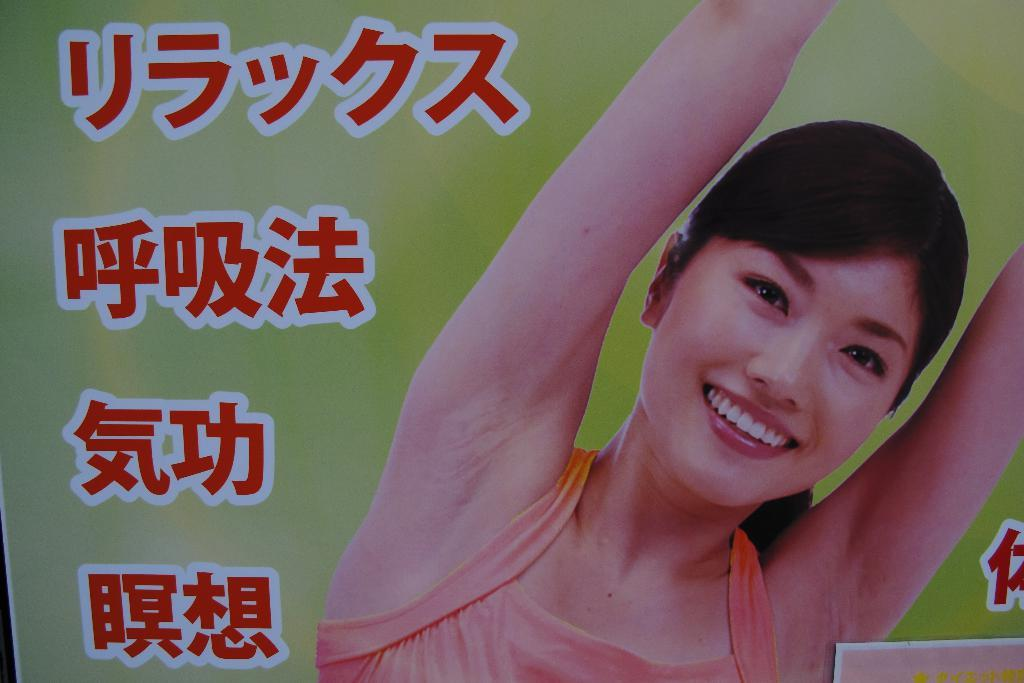What is present in the image that has writing on it? There is a banner in the image with writing on it. What else can be seen on the banner besides the writing? There is an image of a woman on the banner. Where is the basin located in the image? There is no basin present in the image. Is there a spring visible in the image? There is no spring visible in the image. 